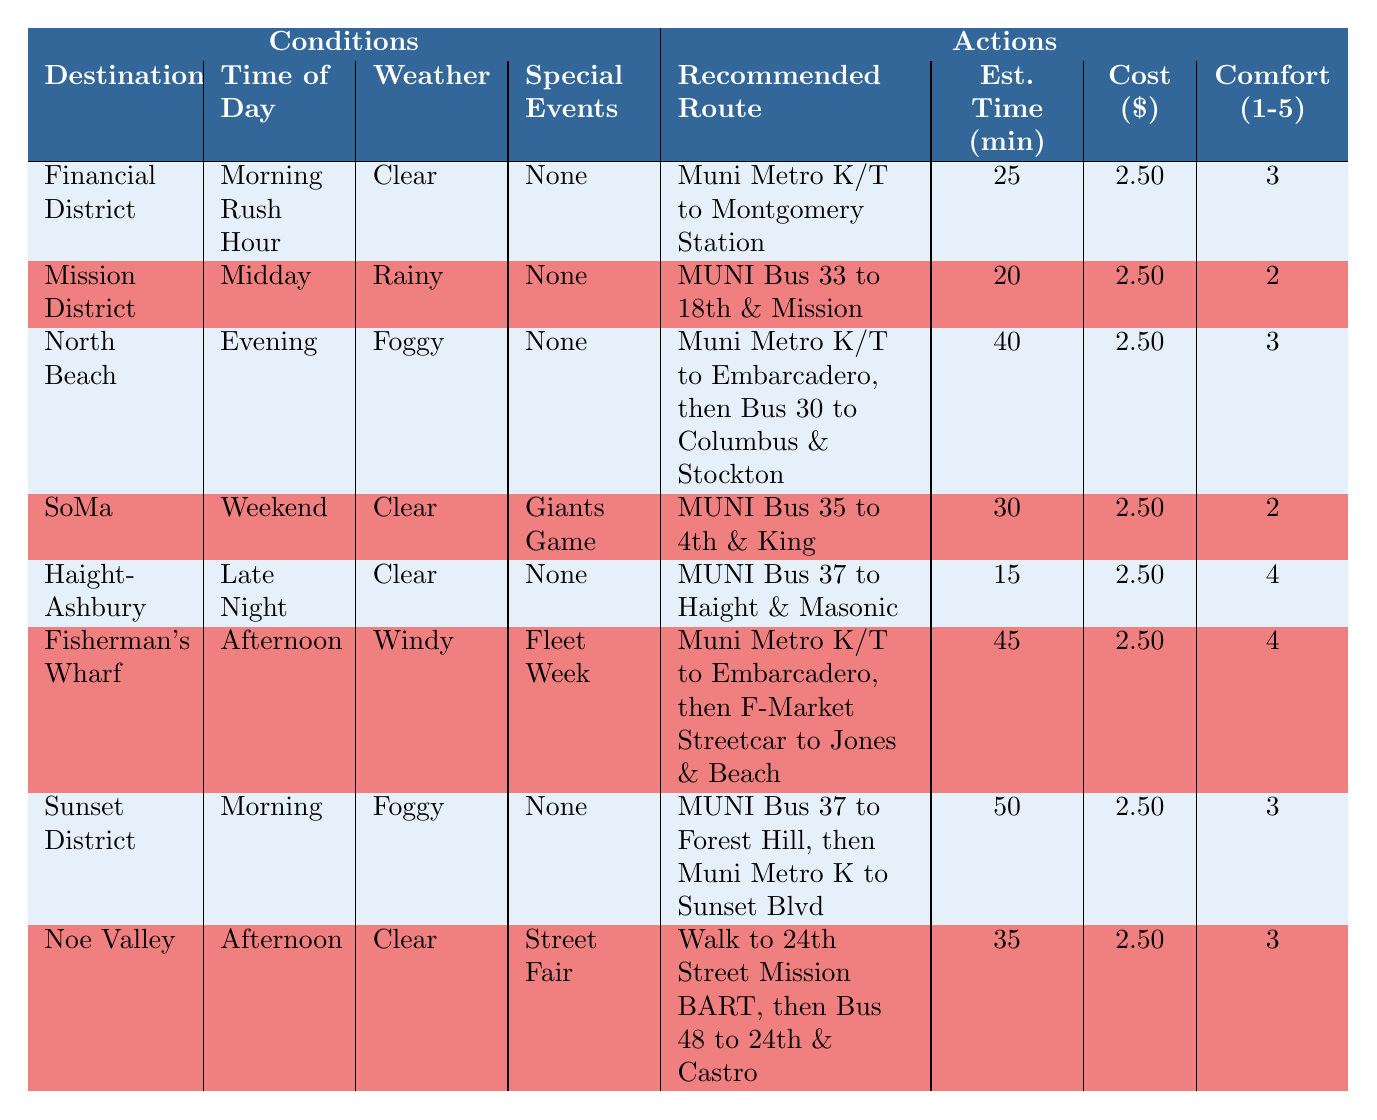What is the recommended route to the Financial District during Morning Rush Hour? The table shows that the recommended route to the Financial District during Morning Rush Hour is "Muni Metro K/T to Montgomery Station."
Answer: Muni Metro K/T to Montgomery Station How long does it take to travel to North Beach in the evening? According to the table, the Estimated Travel Time to North Beach in the evening is 40 minutes.
Answer: 40 minutes Is there a special event when commuting to SoMa on a weekend? The table states that there is a "Giants Game" as a special event when commuting to SoMa on a weekend.
Answer: Yes Which neighborhood has the shortest estimated travel time during midday? The table indicates that the Mission District has the shortest Estimated Travel Time of 20 minutes during midday.
Answer: Mission District What is the average comfort level for traveling to the Sunset District and Fisherman's Wharf? For the Sunset District, the comfort level is 3, and for Fisherman's Wharf, it is 4. The average comfort level is (3 + 4) / 2 = 3.5.
Answer: 3.5 Is the cost of commuting to Noe Valley different from commuting to the Financial District? The table shows the cost for both neighborhoods as $2.50. Therefore, the cost is the same, indicating no difference.
Answer: No What is the recommended route to Haight-Ashbury during Late Night, and what is its estimated travel time? The table indicates that the recommended route to Haight-Ashbury during Late Night is "MUNI Bus 37 to Haight & Masonic," and the estimated travel time is 15 minutes.
Answer: MUNI Bus 37 to Haight & Masonic, 15 minutes What is the difference in estimated travel time between commuting to SoMa on a weekend and to Sunset District in the morning? The estimated travel time to SoMa on a weekend is 30 minutes, while to Sunset District in the morning, it is 50 minutes. The difference is 50 - 30 = 20 minutes.
Answer: 20 minutes What are the weather conditions when traveling to Mission District during midday? The table states that the weather conditions when traveling to the Mission District during midday are "Rainy."
Answer: Rainy 